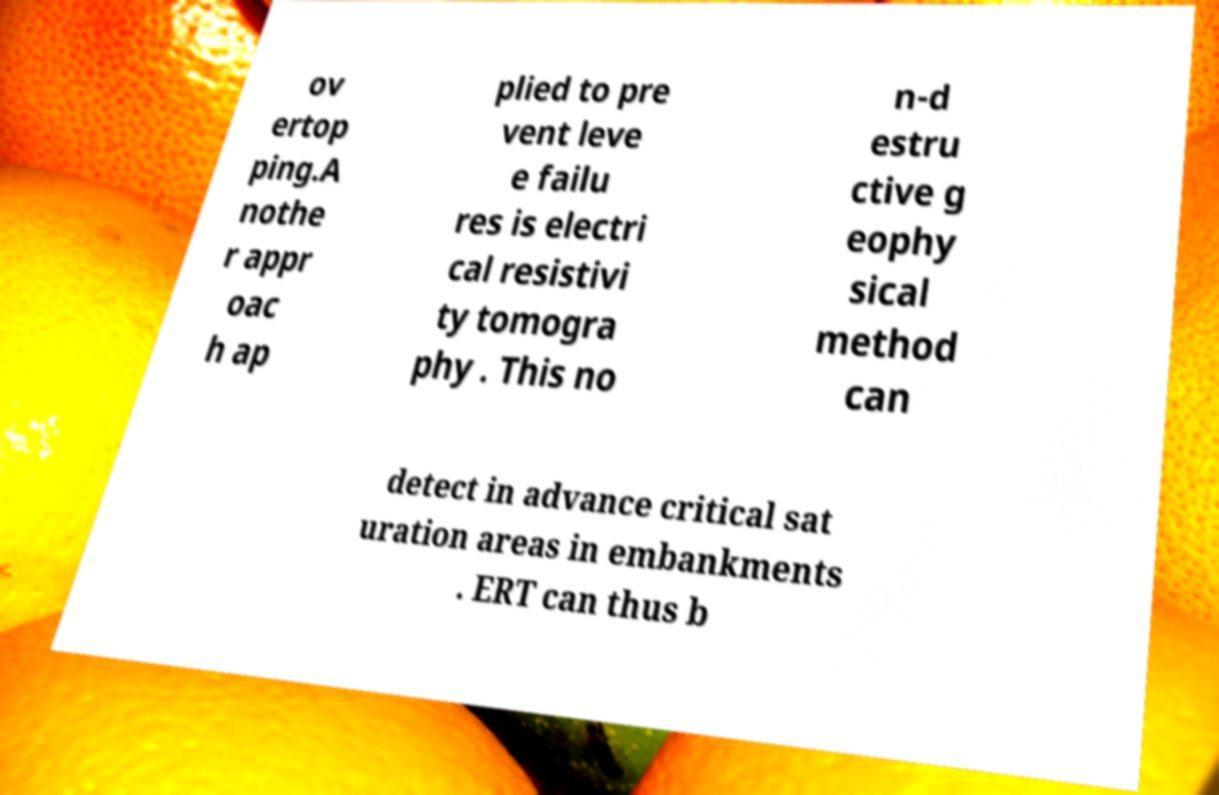Can you read and provide the text displayed in the image?This photo seems to have some interesting text. Can you extract and type it out for me? ov ertop ping.A nothe r appr oac h ap plied to pre vent leve e failu res is electri cal resistivi ty tomogra phy . This no n-d estru ctive g eophy sical method can detect in advance critical sat uration areas in embankments . ERT can thus b 